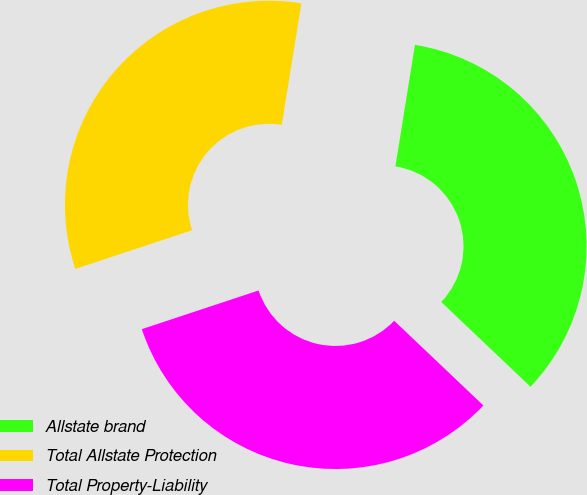Convert chart. <chart><loc_0><loc_0><loc_500><loc_500><pie_chart><fcel>Allstate brand<fcel>Total Allstate Protection<fcel>Total Property-Liability<nl><fcel>34.55%<fcel>32.63%<fcel>32.82%<nl></chart> 